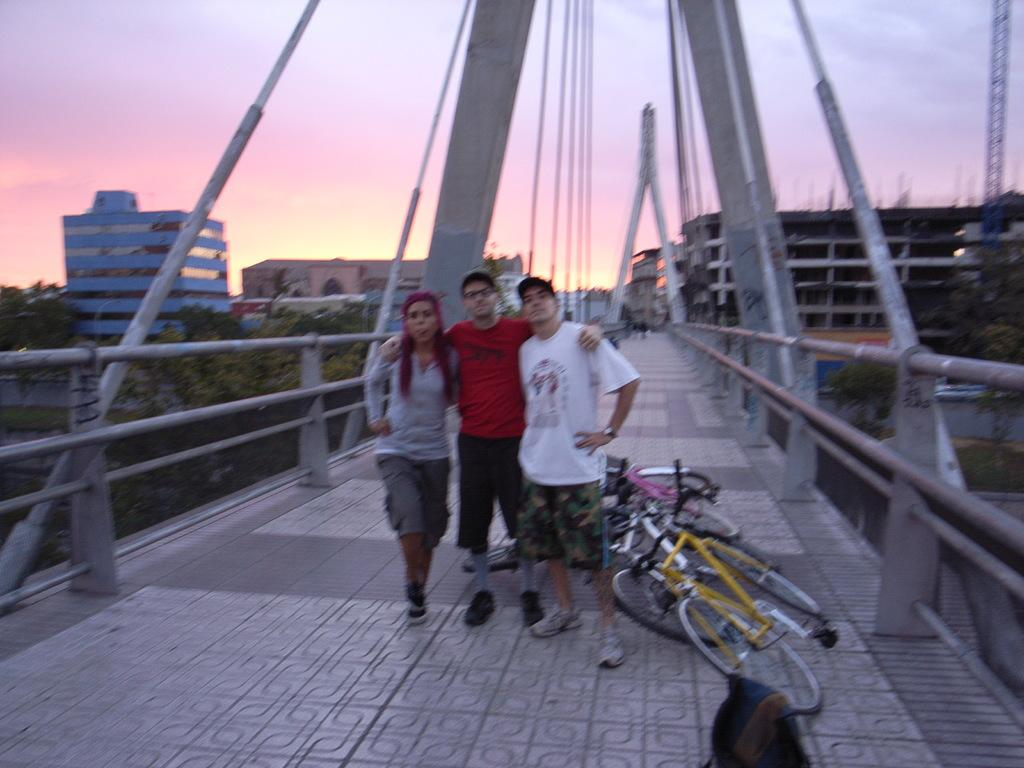What are the people in the image doing? The people in the image are standing on a bridge. What can be seen near the bridge? There are bicycles placed near the bridge. What is visible in the background of the image? There are buildings and trees visible in the background of the image. How does the wind affect the sail in the image? There is no sail present in the image, so the wind's effect cannot be determined. 